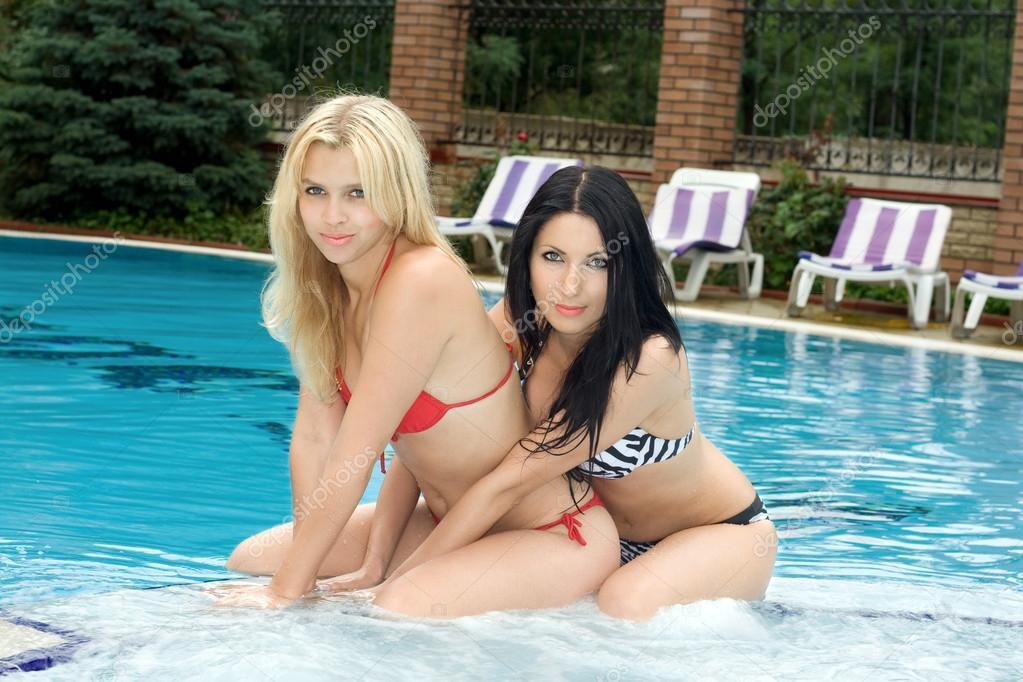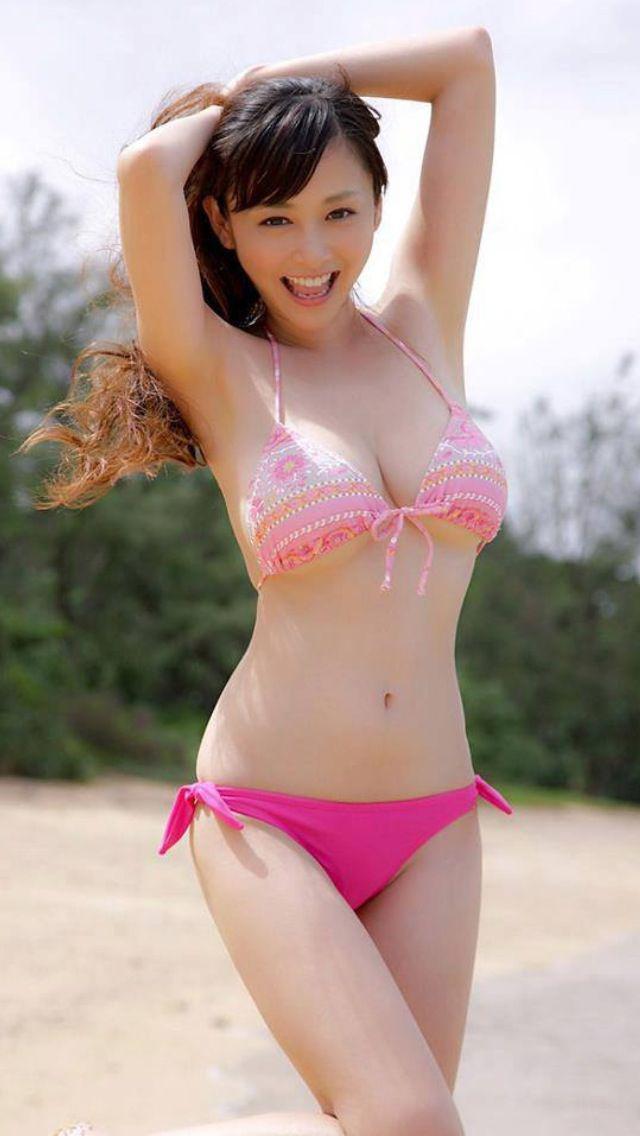The first image is the image on the left, the second image is the image on the right. Assess this claim about the two images: "There are no more than three women.". Correct or not? Answer yes or no. Yes. The first image is the image on the left, the second image is the image on the right. Assess this claim about the two images: "Three camera-facing swimwear models stand side-by-side in front of a swimming pool.". Correct or not? Answer yes or no. No. 